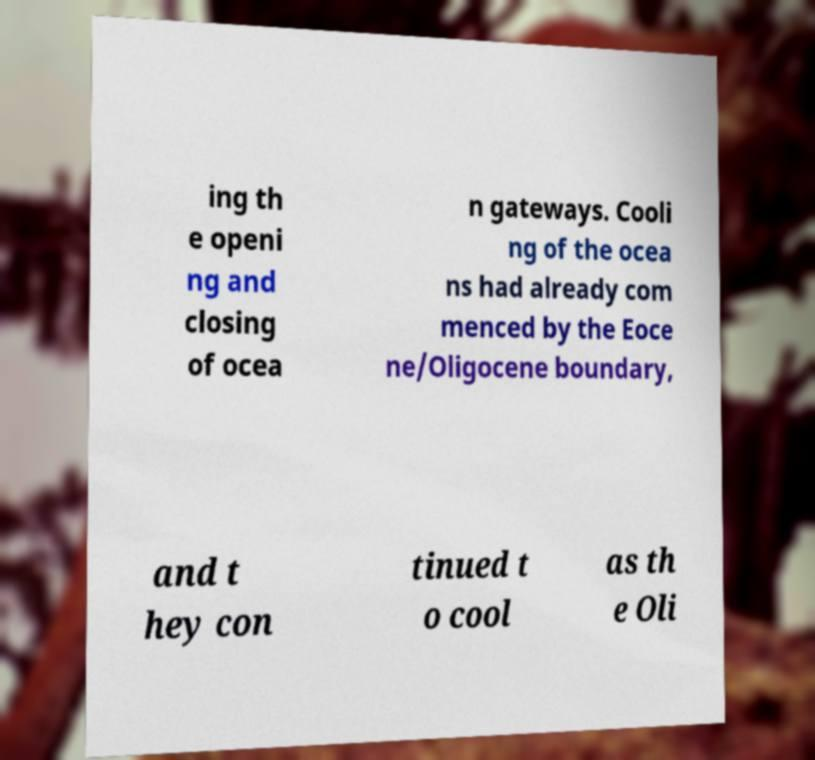There's text embedded in this image that I need extracted. Can you transcribe it verbatim? ing th e openi ng and closing of ocea n gateways. Cooli ng of the ocea ns had already com menced by the Eoce ne/Oligocene boundary, and t hey con tinued t o cool as th e Oli 